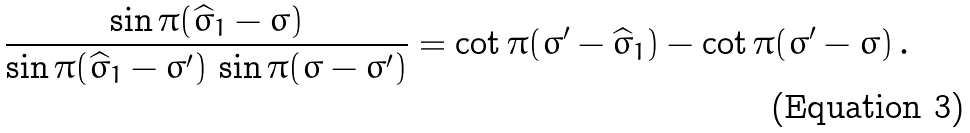Convert formula to latex. <formula><loc_0><loc_0><loc_500><loc_500>\frac { \sin \pi ( \widehat { \sigma } _ { 1 } - \sigma ) } { \sin \pi ( \widehat { \sigma } _ { 1 } - \sigma ^ { \prime } ) \, \sin \pi ( \sigma - \sigma ^ { \prime } ) } = \cot \pi ( \sigma ^ { \prime } - \widehat { \sigma } _ { 1 } ) - \cot \pi ( \sigma ^ { \prime } - \sigma ) \, .</formula> 